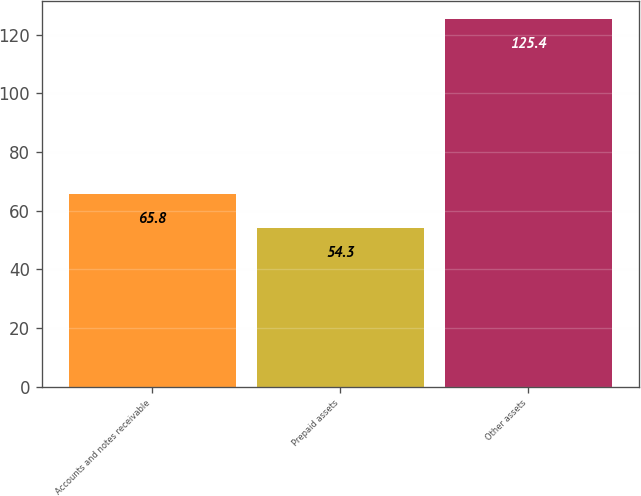Convert chart. <chart><loc_0><loc_0><loc_500><loc_500><bar_chart><fcel>Accounts and notes receivable<fcel>Prepaid assets<fcel>Other assets<nl><fcel>65.8<fcel>54.3<fcel>125.4<nl></chart> 